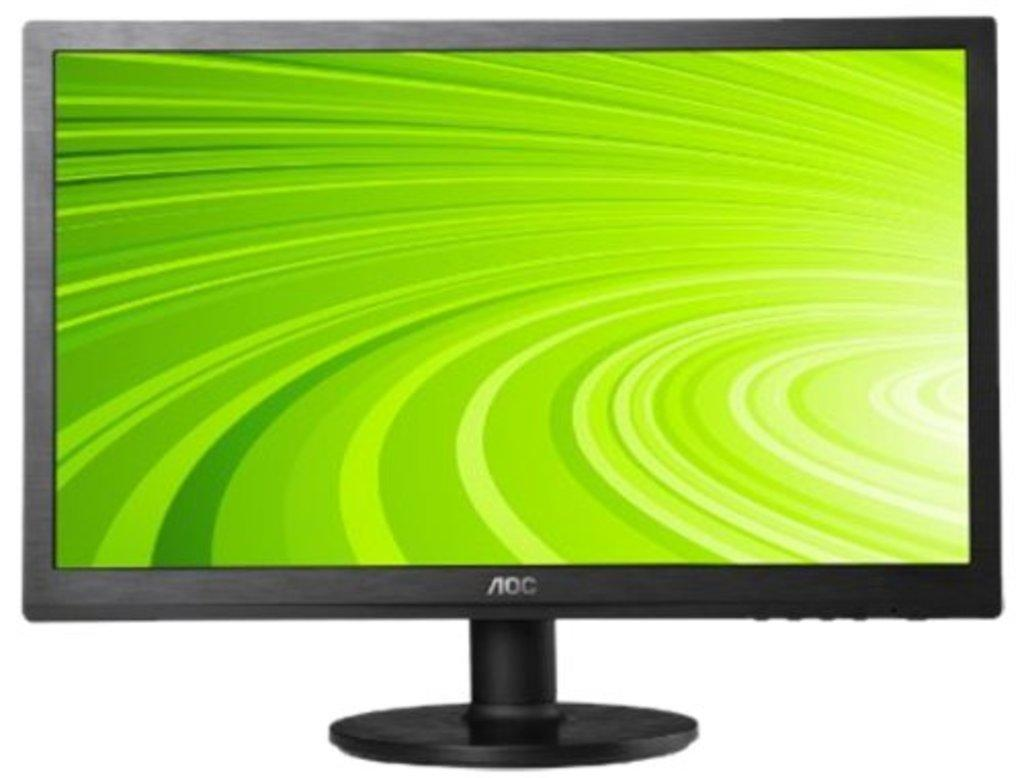<image>
Provide a brief description of the given image. A computer that says AOC and features a green striped background. 